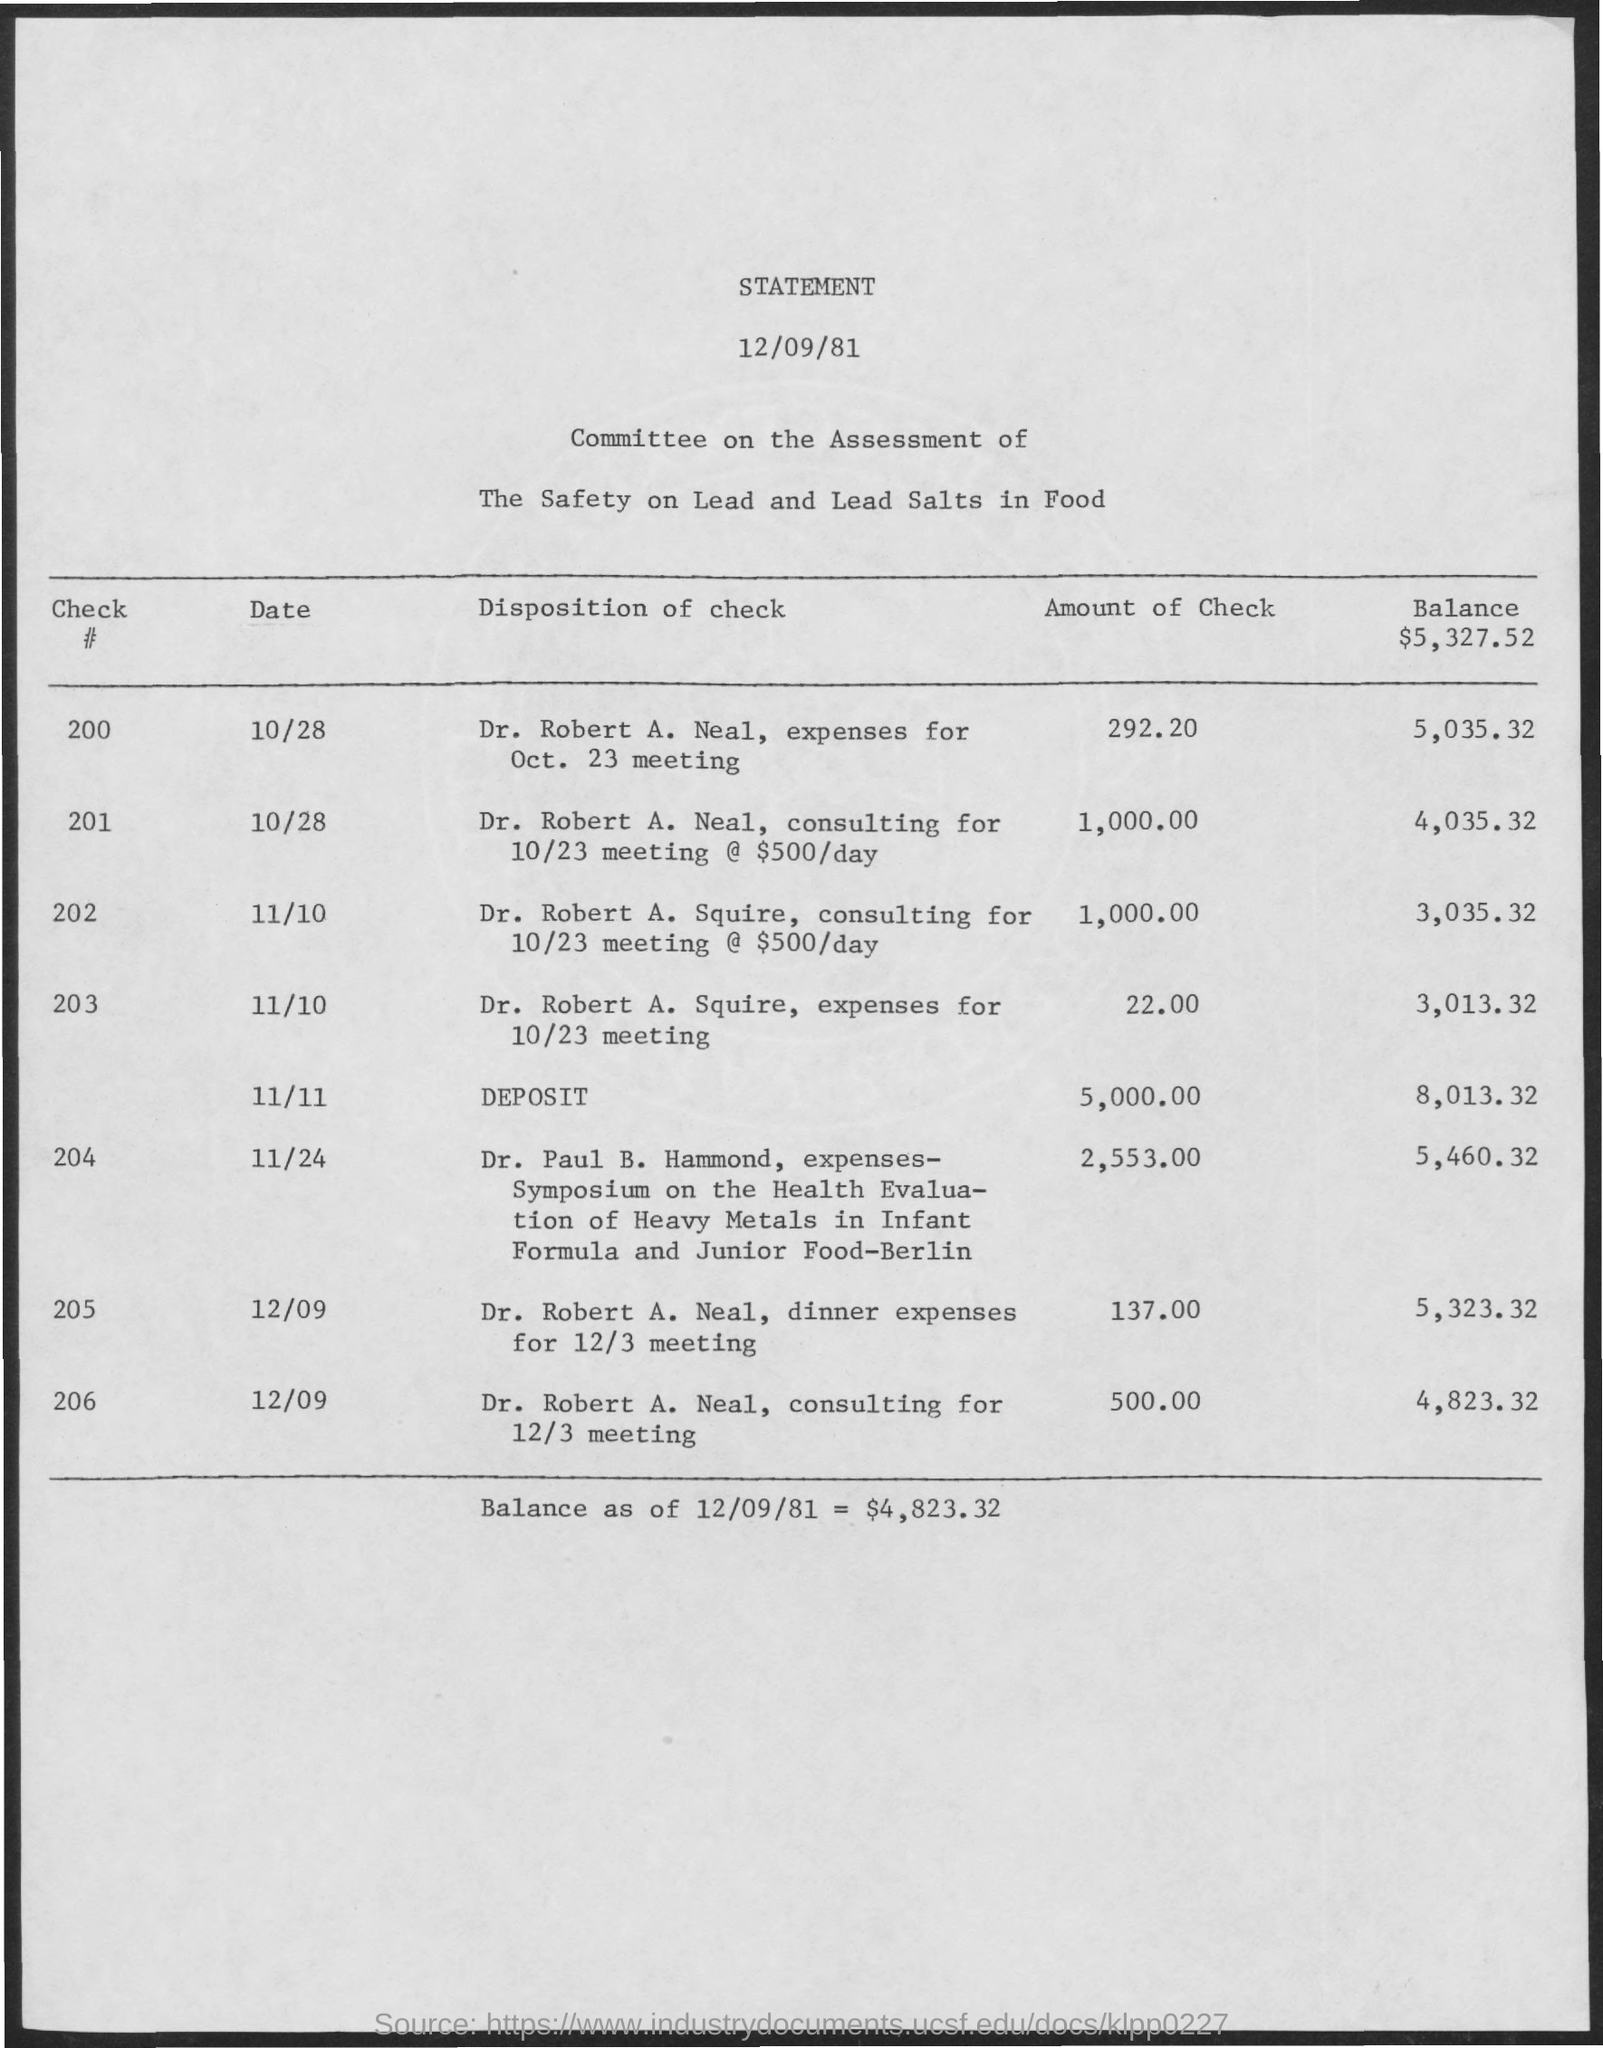Highlight a few significant elements in this photo. As of December 9, 1981, the balance was $4,823.32. 